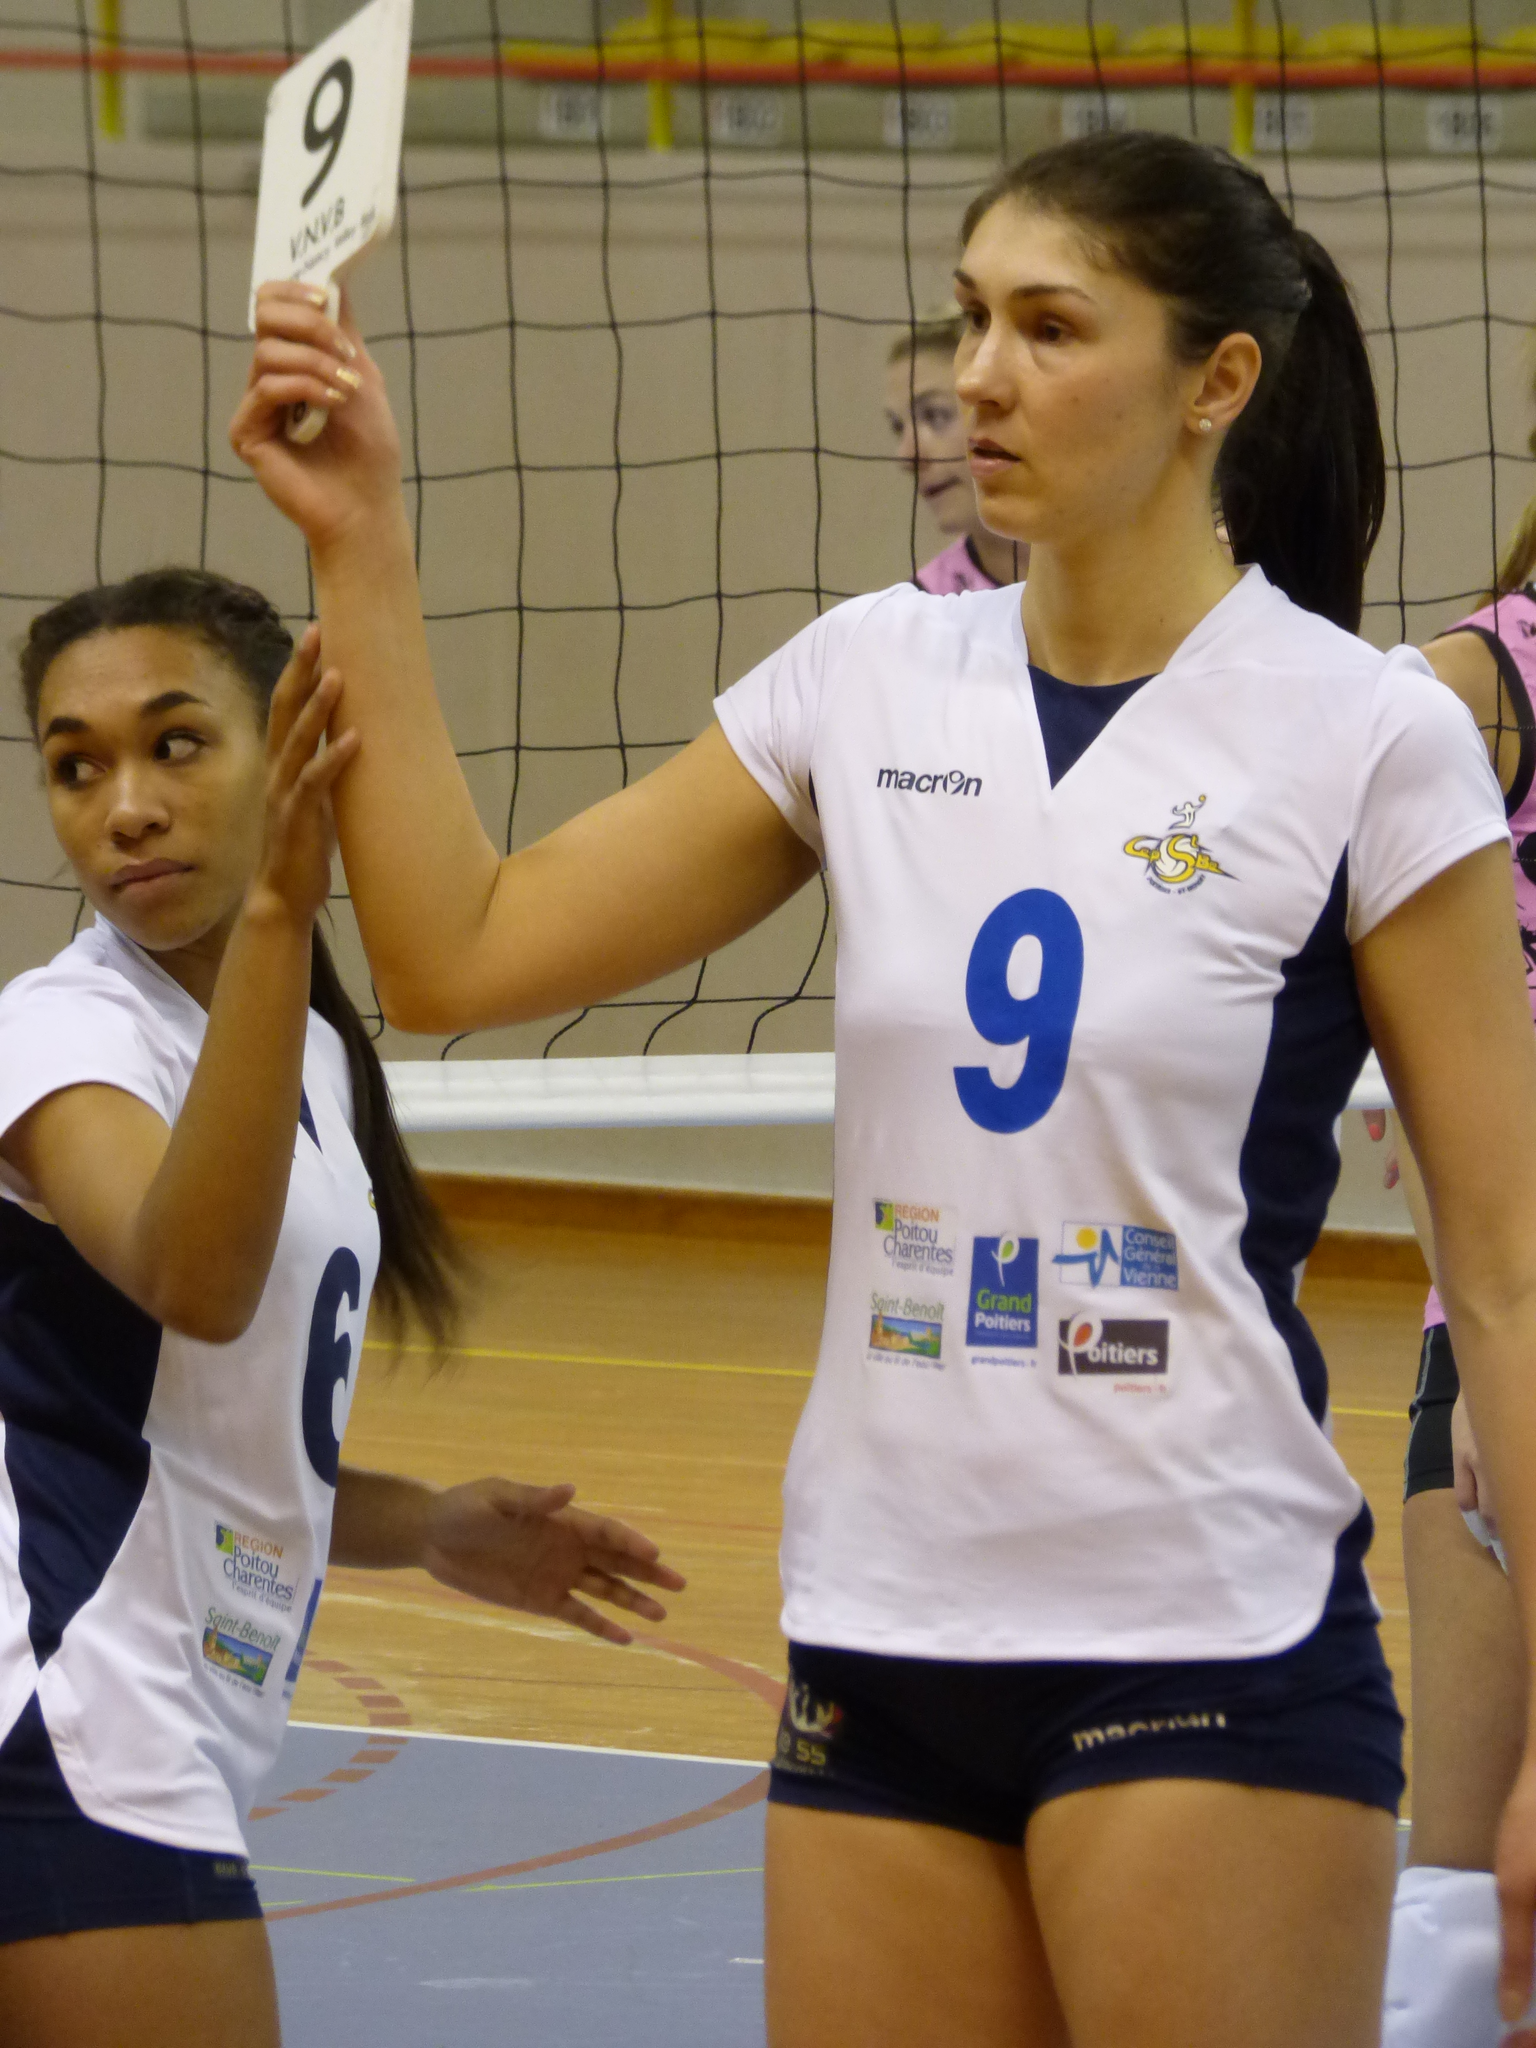What is the number of the right player's jersey?
Provide a succinct answer. 9. 